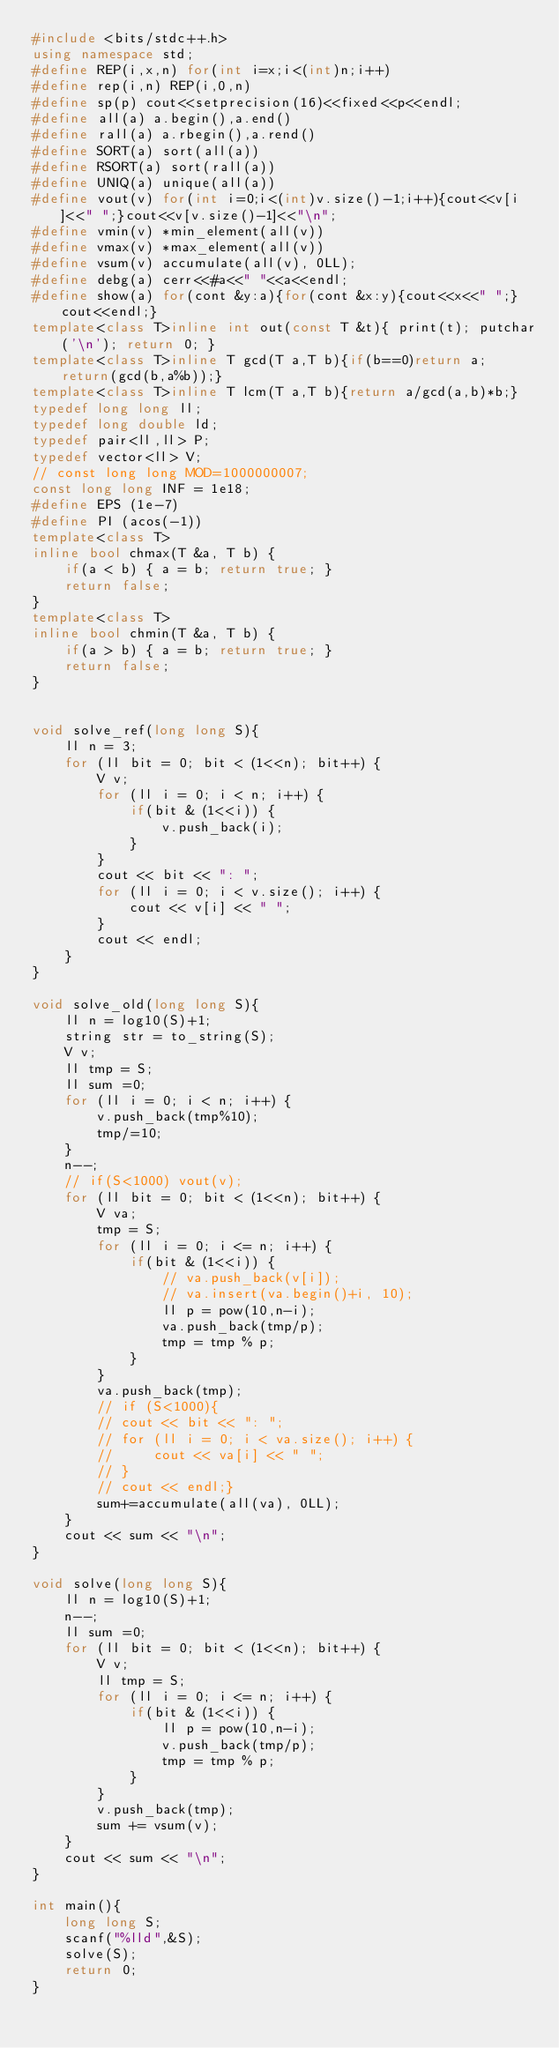<code> <loc_0><loc_0><loc_500><loc_500><_C++_>#include <bits/stdc++.h>
using namespace std;
#define REP(i,x,n) for(int i=x;i<(int)n;i++)
#define rep(i,n) REP(i,0,n)
#define sp(p) cout<<setprecision(16)<<fixed<<p<<endl;
#define all(a) a.begin(),a.end()
#define rall(a) a.rbegin(),a.rend()
#define SORT(a) sort(all(a))
#define RSORT(a) sort(rall(a))
#define UNIQ(a) unique(all(a))
#define vout(v) for(int i=0;i<(int)v.size()-1;i++){cout<<v[i]<<" ";}cout<<v[v.size()-1]<<"\n";
#define vmin(v) *min_element(all(v))
#define vmax(v) *max_element(all(v))
#define vsum(v) accumulate(all(v), 0LL);
#define debg(a) cerr<<#a<<" "<<a<<endl;
#define show(a) for(cont &y:a){for(cont &x:y){cout<<x<<" ";}cout<<endl;}
template<class T>inline int out(const T &t){ print(t); putchar('\n'); return 0; }
template<class T>inline T gcd(T a,T b){if(b==0)return a; return(gcd(b,a%b));}
template<class T>inline T lcm(T a,T b){return a/gcd(a,b)*b;}
typedef long long ll;
typedef long double ld;
typedef pair<ll,ll> P;
typedef vector<ll> V;
// const long long MOD=1000000007;
const long long INF = 1e18;
#define EPS (1e-7)
#define PI (acos(-1))
template<class T>
inline bool chmax(T &a, T b) {
    if(a < b) { a = b; return true; }
    return false;
}
template<class T>
inline bool chmin(T &a, T b) {
    if(a > b) { a = b; return true; }
    return false;
}


void solve_ref(long long S){
    ll n = 3;
    for (ll bit = 0; bit < (1<<n); bit++) {
        V v;
        for (ll i = 0; i < n; i++) {
            if(bit & (1<<i)) {
                v.push_back(i);
            }
        }
        cout << bit << ": ";
        for (ll i = 0; i < v.size(); i++) {
            cout << v[i] << " ";
        }
        cout << endl;
    }
}

void solve_old(long long S){
    ll n = log10(S)+1;
    string str = to_string(S);
    V v;
    ll tmp = S;
    ll sum =0;
    for (ll i = 0; i < n; i++) {
        v.push_back(tmp%10);
        tmp/=10;
    }
    n--;
    // if(S<1000) vout(v);
    for (ll bit = 0; bit < (1<<n); bit++) {
        V va;
        tmp = S;
        for (ll i = 0; i <= n; i++) {
            if(bit & (1<<i)) {
                // va.push_back(v[i]);
                // va.insert(va.begin()+i, 10);
                ll p = pow(10,n-i);
                va.push_back(tmp/p);
                tmp = tmp % p;
            }
        }
        va.push_back(tmp);
        // if (S<1000){
        // cout << bit << ": ";
        // for (ll i = 0; i < va.size(); i++) {
        //     cout << va[i] << " ";
        // }
        // cout << endl;}
        sum+=accumulate(all(va), 0LL);
    }
    cout << sum << "\n";
}

void solve(long long S){
    ll n = log10(S)+1;
    n--;
    ll sum =0;
    for (ll bit = 0; bit < (1<<n); bit++) {
        V v;
        ll tmp = S;
        for (ll i = 0; i <= n; i++) {
            if(bit & (1<<i)) {
                ll p = pow(10,n-i);
                v.push_back(tmp/p);
                tmp = tmp % p;
            }
        }
        v.push_back(tmp);
        sum += vsum(v);
    }
    cout << sum << "\n";
}

int main(){
    long long S;
    scanf("%lld",&S);
    solve(S);
    return 0;
}
</code> 